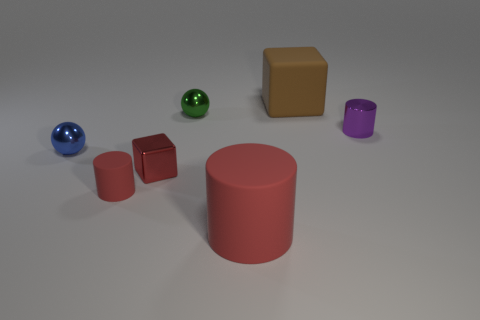Subtract all rubber cylinders. How many cylinders are left? 1 Add 2 small blue shiny balls. How many objects exist? 9 Subtract all spheres. How many objects are left? 5 Subtract all purple cylinders. How many cylinders are left? 2 Subtract 2 cylinders. How many cylinders are left? 1 Subtract all matte cylinders. Subtract all matte cubes. How many objects are left? 4 Add 5 tiny red shiny cubes. How many tiny red shiny cubes are left? 6 Add 4 red cylinders. How many red cylinders exist? 6 Subtract 1 purple cylinders. How many objects are left? 6 Subtract all purple balls. Subtract all purple blocks. How many balls are left? 2 